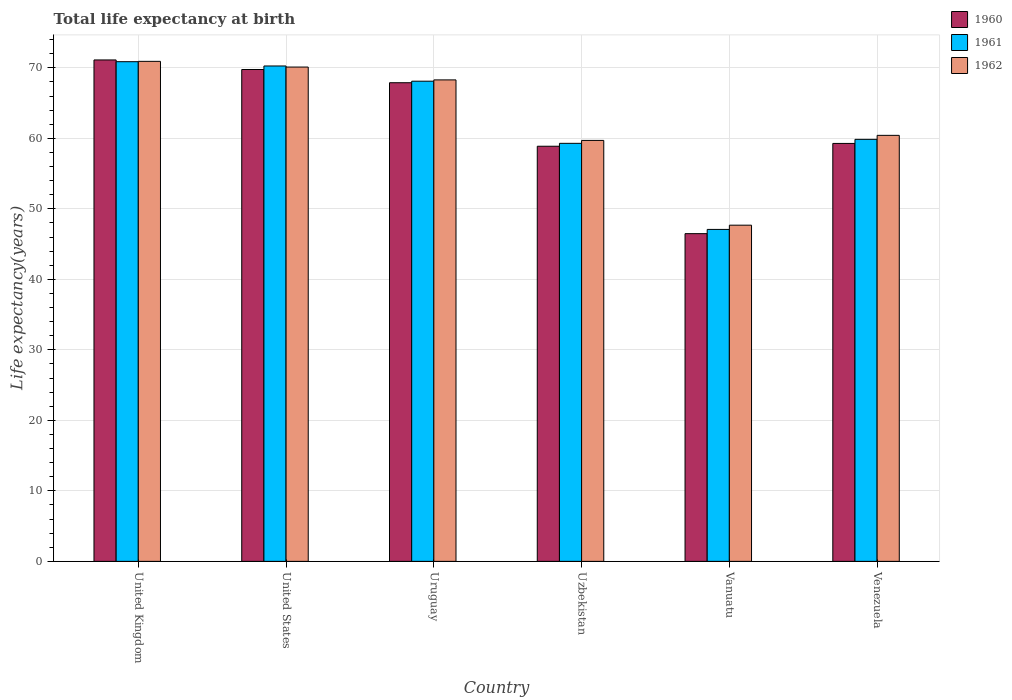How many different coloured bars are there?
Make the answer very short. 3. How many groups of bars are there?
Offer a terse response. 6. Are the number of bars per tick equal to the number of legend labels?
Give a very brief answer. Yes. Are the number of bars on each tick of the X-axis equal?
Give a very brief answer. Yes. What is the label of the 4th group of bars from the left?
Offer a very short reply. Uzbekistan. What is the life expectancy at birth in in 1960 in Venezuela?
Offer a very short reply. 59.29. Across all countries, what is the maximum life expectancy at birth in in 1962?
Give a very brief answer. 70.93. Across all countries, what is the minimum life expectancy at birth in in 1960?
Provide a succinct answer. 46.49. In which country was the life expectancy at birth in in 1960 maximum?
Your response must be concise. United Kingdom. In which country was the life expectancy at birth in in 1962 minimum?
Make the answer very short. Vanuatu. What is the total life expectancy at birth in in 1962 in the graph?
Give a very brief answer. 377.17. What is the difference between the life expectancy at birth in in 1960 in United States and that in Vanuatu?
Ensure brevity in your answer.  23.28. What is the difference between the life expectancy at birth in in 1960 in Venezuela and the life expectancy at birth in in 1961 in Vanuatu?
Provide a short and direct response. 12.2. What is the average life expectancy at birth in in 1961 per country?
Your response must be concise. 62.58. What is the difference between the life expectancy at birth in of/in 1962 and life expectancy at birth in of/in 1961 in Vanuatu?
Give a very brief answer. 0.6. What is the ratio of the life expectancy at birth in in 1960 in United States to that in Vanuatu?
Offer a terse response. 1.5. Is the life expectancy at birth in in 1962 in Uzbekistan less than that in Venezuela?
Provide a short and direct response. Yes. What is the difference between the highest and the second highest life expectancy at birth in in 1962?
Offer a very short reply. 1.82. What is the difference between the highest and the lowest life expectancy at birth in in 1962?
Your answer should be very brief. 23.24. Is the sum of the life expectancy at birth in in 1961 in Uzbekistan and Vanuatu greater than the maximum life expectancy at birth in in 1960 across all countries?
Keep it short and to the point. Yes. What does the 2nd bar from the right in Uzbekistan represents?
Offer a very short reply. 1961. Is it the case that in every country, the sum of the life expectancy at birth in in 1961 and life expectancy at birth in in 1960 is greater than the life expectancy at birth in in 1962?
Provide a short and direct response. Yes. How many bars are there?
Your answer should be very brief. 18. Are all the bars in the graph horizontal?
Ensure brevity in your answer.  No. Does the graph contain grids?
Offer a terse response. Yes. Where does the legend appear in the graph?
Provide a short and direct response. Top right. What is the title of the graph?
Offer a terse response. Total life expectancy at birth. Does "1977" appear as one of the legend labels in the graph?
Your answer should be compact. No. What is the label or title of the X-axis?
Make the answer very short. Country. What is the label or title of the Y-axis?
Your answer should be compact. Life expectancy(years). What is the Life expectancy(years) in 1960 in United Kingdom?
Give a very brief answer. 71.13. What is the Life expectancy(years) in 1961 in United Kingdom?
Offer a terse response. 70.88. What is the Life expectancy(years) of 1962 in United Kingdom?
Give a very brief answer. 70.93. What is the Life expectancy(years) in 1960 in United States?
Your response must be concise. 69.77. What is the Life expectancy(years) in 1961 in United States?
Make the answer very short. 70.27. What is the Life expectancy(years) in 1962 in United States?
Offer a terse response. 70.12. What is the Life expectancy(years) of 1960 in Uruguay?
Make the answer very short. 67.9. What is the Life expectancy(years) of 1961 in Uruguay?
Your response must be concise. 68.11. What is the Life expectancy(years) of 1962 in Uruguay?
Give a very brief answer. 68.3. What is the Life expectancy(years) in 1960 in Uzbekistan?
Your answer should be very brief. 58.89. What is the Life expectancy(years) in 1961 in Uzbekistan?
Offer a very short reply. 59.3. What is the Life expectancy(years) of 1962 in Uzbekistan?
Offer a very short reply. 59.71. What is the Life expectancy(years) in 1960 in Vanuatu?
Offer a terse response. 46.49. What is the Life expectancy(years) in 1961 in Vanuatu?
Your answer should be very brief. 47.09. What is the Life expectancy(years) of 1962 in Vanuatu?
Your response must be concise. 47.69. What is the Life expectancy(years) of 1960 in Venezuela?
Your answer should be compact. 59.29. What is the Life expectancy(years) in 1961 in Venezuela?
Give a very brief answer. 59.86. What is the Life expectancy(years) of 1962 in Venezuela?
Give a very brief answer. 60.43. Across all countries, what is the maximum Life expectancy(years) in 1960?
Offer a terse response. 71.13. Across all countries, what is the maximum Life expectancy(years) in 1961?
Ensure brevity in your answer.  70.88. Across all countries, what is the maximum Life expectancy(years) in 1962?
Your answer should be compact. 70.93. Across all countries, what is the minimum Life expectancy(years) of 1960?
Offer a terse response. 46.49. Across all countries, what is the minimum Life expectancy(years) of 1961?
Your response must be concise. 47.09. Across all countries, what is the minimum Life expectancy(years) of 1962?
Give a very brief answer. 47.69. What is the total Life expectancy(years) in 1960 in the graph?
Offer a very short reply. 373.45. What is the total Life expectancy(years) in 1961 in the graph?
Your answer should be compact. 375.51. What is the total Life expectancy(years) of 1962 in the graph?
Offer a terse response. 377.17. What is the difference between the Life expectancy(years) in 1960 in United Kingdom and that in United States?
Provide a succinct answer. 1.36. What is the difference between the Life expectancy(years) in 1961 in United Kingdom and that in United States?
Keep it short and to the point. 0.61. What is the difference between the Life expectancy(years) in 1962 in United Kingdom and that in United States?
Provide a succinct answer. 0.81. What is the difference between the Life expectancy(years) of 1960 in United Kingdom and that in Uruguay?
Offer a very short reply. 3.23. What is the difference between the Life expectancy(years) of 1961 in United Kingdom and that in Uruguay?
Your answer should be very brief. 2.77. What is the difference between the Life expectancy(years) in 1962 in United Kingdom and that in Uruguay?
Your response must be concise. 2.63. What is the difference between the Life expectancy(years) in 1960 in United Kingdom and that in Uzbekistan?
Your response must be concise. 12.24. What is the difference between the Life expectancy(years) of 1961 in United Kingdom and that in Uzbekistan?
Your response must be concise. 11.58. What is the difference between the Life expectancy(years) in 1962 in United Kingdom and that in Uzbekistan?
Ensure brevity in your answer.  11.21. What is the difference between the Life expectancy(years) in 1960 in United Kingdom and that in Vanuatu?
Provide a short and direct response. 24.64. What is the difference between the Life expectancy(years) in 1961 in United Kingdom and that in Vanuatu?
Give a very brief answer. 23.79. What is the difference between the Life expectancy(years) in 1962 in United Kingdom and that in Vanuatu?
Provide a succinct answer. 23.24. What is the difference between the Life expectancy(years) in 1960 in United Kingdom and that in Venezuela?
Provide a succinct answer. 11.84. What is the difference between the Life expectancy(years) of 1961 in United Kingdom and that in Venezuela?
Your answer should be compact. 11.02. What is the difference between the Life expectancy(years) in 1962 in United Kingdom and that in Venezuela?
Give a very brief answer. 10.5. What is the difference between the Life expectancy(years) in 1960 in United States and that in Uruguay?
Offer a very short reply. 1.87. What is the difference between the Life expectancy(years) of 1961 in United States and that in Uruguay?
Keep it short and to the point. 2.16. What is the difference between the Life expectancy(years) in 1962 in United States and that in Uruguay?
Keep it short and to the point. 1.82. What is the difference between the Life expectancy(years) of 1960 in United States and that in Uzbekistan?
Provide a short and direct response. 10.89. What is the difference between the Life expectancy(years) in 1961 in United States and that in Uzbekistan?
Provide a short and direct response. 10.97. What is the difference between the Life expectancy(years) in 1962 in United States and that in Uzbekistan?
Provide a short and direct response. 10.41. What is the difference between the Life expectancy(years) of 1960 in United States and that in Vanuatu?
Ensure brevity in your answer.  23.28. What is the difference between the Life expectancy(years) of 1961 in United States and that in Vanuatu?
Your answer should be very brief. 23.18. What is the difference between the Life expectancy(years) in 1962 in United States and that in Vanuatu?
Offer a very short reply. 22.43. What is the difference between the Life expectancy(years) in 1960 in United States and that in Venezuela?
Provide a succinct answer. 10.49. What is the difference between the Life expectancy(years) of 1961 in United States and that in Venezuela?
Your response must be concise. 10.41. What is the difference between the Life expectancy(years) in 1962 in United States and that in Venezuela?
Provide a short and direct response. 9.69. What is the difference between the Life expectancy(years) in 1960 in Uruguay and that in Uzbekistan?
Offer a very short reply. 9.01. What is the difference between the Life expectancy(years) in 1961 in Uruguay and that in Uzbekistan?
Keep it short and to the point. 8.82. What is the difference between the Life expectancy(years) in 1962 in Uruguay and that in Uzbekistan?
Keep it short and to the point. 8.58. What is the difference between the Life expectancy(years) in 1960 in Uruguay and that in Vanuatu?
Your answer should be very brief. 21.41. What is the difference between the Life expectancy(years) in 1961 in Uruguay and that in Vanuatu?
Provide a succinct answer. 21.02. What is the difference between the Life expectancy(years) of 1962 in Uruguay and that in Vanuatu?
Your answer should be very brief. 20.61. What is the difference between the Life expectancy(years) in 1960 in Uruguay and that in Venezuela?
Your answer should be very brief. 8.61. What is the difference between the Life expectancy(years) in 1961 in Uruguay and that in Venezuela?
Ensure brevity in your answer.  8.25. What is the difference between the Life expectancy(years) of 1962 in Uruguay and that in Venezuela?
Your answer should be compact. 7.87. What is the difference between the Life expectancy(years) of 1960 in Uzbekistan and that in Vanuatu?
Give a very brief answer. 12.4. What is the difference between the Life expectancy(years) in 1961 in Uzbekistan and that in Vanuatu?
Your answer should be compact. 12.21. What is the difference between the Life expectancy(years) of 1962 in Uzbekistan and that in Vanuatu?
Make the answer very short. 12.02. What is the difference between the Life expectancy(years) of 1960 in Uzbekistan and that in Venezuela?
Your answer should be compact. -0.4. What is the difference between the Life expectancy(years) of 1961 in Uzbekistan and that in Venezuela?
Your response must be concise. -0.56. What is the difference between the Life expectancy(years) in 1962 in Uzbekistan and that in Venezuela?
Your answer should be very brief. -0.72. What is the difference between the Life expectancy(years) in 1960 in Vanuatu and that in Venezuela?
Offer a very short reply. -12.8. What is the difference between the Life expectancy(years) of 1961 in Vanuatu and that in Venezuela?
Your answer should be very brief. -12.77. What is the difference between the Life expectancy(years) of 1962 in Vanuatu and that in Venezuela?
Your answer should be compact. -12.74. What is the difference between the Life expectancy(years) of 1960 in United Kingdom and the Life expectancy(years) of 1961 in United States?
Provide a short and direct response. 0.86. What is the difference between the Life expectancy(years) of 1960 in United Kingdom and the Life expectancy(years) of 1962 in United States?
Your answer should be very brief. 1.01. What is the difference between the Life expectancy(years) in 1961 in United Kingdom and the Life expectancy(years) in 1962 in United States?
Give a very brief answer. 0.76. What is the difference between the Life expectancy(years) in 1960 in United Kingdom and the Life expectancy(years) in 1961 in Uruguay?
Offer a very short reply. 3.01. What is the difference between the Life expectancy(years) in 1960 in United Kingdom and the Life expectancy(years) in 1962 in Uruguay?
Ensure brevity in your answer.  2.83. What is the difference between the Life expectancy(years) in 1961 in United Kingdom and the Life expectancy(years) in 1962 in Uruguay?
Provide a short and direct response. 2.58. What is the difference between the Life expectancy(years) in 1960 in United Kingdom and the Life expectancy(years) in 1961 in Uzbekistan?
Keep it short and to the point. 11.83. What is the difference between the Life expectancy(years) of 1960 in United Kingdom and the Life expectancy(years) of 1962 in Uzbekistan?
Your answer should be very brief. 11.41. What is the difference between the Life expectancy(years) of 1961 in United Kingdom and the Life expectancy(years) of 1962 in Uzbekistan?
Make the answer very short. 11.16. What is the difference between the Life expectancy(years) of 1960 in United Kingdom and the Life expectancy(years) of 1961 in Vanuatu?
Make the answer very short. 24.04. What is the difference between the Life expectancy(years) of 1960 in United Kingdom and the Life expectancy(years) of 1962 in Vanuatu?
Keep it short and to the point. 23.44. What is the difference between the Life expectancy(years) of 1961 in United Kingdom and the Life expectancy(years) of 1962 in Vanuatu?
Make the answer very short. 23.19. What is the difference between the Life expectancy(years) in 1960 in United Kingdom and the Life expectancy(years) in 1961 in Venezuela?
Offer a very short reply. 11.26. What is the difference between the Life expectancy(years) in 1960 in United Kingdom and the Life expectancy(years) in 1962 in Venezuela?
Make the answer very short. 10.7. What is the difference between the Life expectancy(years) in 1961 in United Kingdom and the Life expectancy(years) in 1962 in Venezuela?
Provide a short and direct response. 10.45. What is the difference between the Life expectancy(years) in 1960 in United States and the Life expectancy(years) in 1961 in Uruguay?
Offer a very short reply. 1.66. What is the difference between the Life expectancy(years) of 1960 in United States and the Life expectancy(years) of 1962 in Uruguay?
Keep it short and to the point. 1.47. What is the difference between the Life expectancy(years) in 1961 in United States and the Life expectancy(years) in 1962 in Uruguay?
Offer a terse response. 1.97. What is the difference between the Life expectancy(years) in 1960 in United States and the Life expectancy(years) in 1961 in Uzbekistan?
Provide a short and direct response. 10.47. What is the difference between the Life expectancy(years) of 1960 in United States and the Life expectancy(years) of 1962 in Uzbekistan?
Make the answer very short. 10.06. What is the difference between the Life expectancy(years) in 1961 in United States and the Life expectancy(years) in 1962 in Uzbekistan?
Provide a short and direct response. 10.56. What is the difference between the Life expectancy(years) of 1960 in United States and the Life expectancy(years) of 1961 in Vanuatu?
Give a very brief answer. 22.68. What is the difference between the Life expectancy(years) in 1960 in United States and the Life expectancy(years) in 1962 in Vanuatu?
Offer a terse response. 22.08. What is the difference between the Life expectancy(years) of 1961 in United States and the Life expectancy(years) of 1962 in Vanuatu?
Give a very brief answer. 22.58. What is the difference between the Life expectancy(years) of 1960 in United States and the Life expectancy(years) of 1961 in Venezuela?
Your response must be concise. 9.91. What is the difference between the Life expectancy(years) of 1960 in United States and the Life expectancy(years) of 1962 in Venezuela?
Offer a terse response. 9.34. What is the difference between the Life expectancy(years) in 1961 in United States and the Life expectancy(years) in 1962 in Venezuela?
Your answer should be very brief. 9.84. What is the difference between the Life expectancy(years) of 1960 in Uruguay and the Life expectancy(years) of 1961 in Uzbekistan?
Your response must be concise. 8.6. What is the difference between the Life expectancy(years) of 1960 in Uruguay and the Life expectancy(years) of 1962 in Uzbekistan?
Your response must be concise. 8.18. What is the difference between the Life expectancy(years) of 1961 in Uruguay and the Life expectancy(years) of 1962 in Uzbekistan?
Offer a terse response. 8.4. What is the difference between the Life expectancy(years) of 1960 in Uruguay and the Life expectancy(years) of 1961 in Vanuatu?
Give a very brief answer. 20.81. What is the difference between the Life expectancy(years) in 1960 in Uruguay and the Life expectancy(years) in 1962 in Vanuatu?
Make the answer very short. 20.21. What is the difference between the Life expectancy(years) of 1961 in Uruguay and the Life expectancy(years) of 1962 in Vanuatu?
Provide a short and direct response. 20.42. What is the difference between the Life expectancy(years) of 1960 in Uruguay and the Life expectancy(years) of 1961 in Venezuela?
Provide a short and direct response. 8.03. What is the difference between the Life expectancy(years) in 1960 in Uruguay and the Life expectancy(years) in 1962 in Venezuela?
Ensure brevity in your answer.  7.47. What is the difference between the Life expectancy(years) of 1961 in Uruguay and the Life expectancy(years) of 1962 in Venezuela?
Give a very brief answer. 7.68. What is the difference between the Life expectancy(years) in 1960 in Uzbekistan and the Life expectancy(years) in 1961 in Vanuatu?
Offer a terse response. 11.8. What is the difference between the Life expectancy(years) in 1960 in Uzbekistan and the Life expectancy(years) in 1962 in Vanuatu?
Keep it short and to the point. 11.2. What is the difference between the Life expectancy(years) in 1961 in Uzbekistan and the Life expectancy(years) in 1962 in Vanuatu?
Provide a short and direct response. 11.61. What is the difference between the Life expectancy(years) in 1960 in Uzbekistan and the Life expectancy(years) in 1961 in Venezuela?
Provide a succinct answer. -0.98. What is the difference between the Life expectancy(years) of 1960 in Uzbekistan and the Life expectancy(years) of 1962 in Venezuela?
Your answer should be very brief. -1.54. What is the difference between the Life expectancy(years) of 1961 in Uzbekistan and the Life expectancy(years) of 1962 in Venezuela?
Ensure brevity in your answer.  -1.13. What is the difference between the Life expectancy(years) in 1960 in Vanuatu and the Life expectancy(years) in 1961 in Venezuela?
Offer a very short reply. -13.38. What is the difference between the Life expectancy(years) of 1960 in Vanuatu and the Life expectancy(years) of 1962 in Venezuela?
Ensure brevity in your answer.  -13.94. What is the difference between the Life expectancy(years) of 1961 in Vanuatu and the Life expectancy(years) of 1962 in Venezuela?
Make the answer very short. -13.34. What is the average Life expectancy(years) of 1960 per country?
Your response must be concise. 62.24. What is the average Life expectancy(years) in 1961 per country?
Offer a very short reply. 62.59. What is the average Life expectancy(years) of 1962 per country?
Your answer should be very brief. 62.86. What is the difference between the Life expectancy(years) of 1960 and Life expectancy(years) of 1961 in United Kingdom?
Provide a succinct answer. 0.25. What is the difference between the Life expectancy(years) of 1961 and Life expectancy(years) of 1962 in United Kingdom?
Your answer should be very brief. -0.05. What is the difference between the Life expectancy(years) in 1960 and Life expectancy(years) in 1961 in United States?
Provide a short and direct response. -0.5. What is the difference between the Life expectancy(years) in 1960 and Life expectancy(years) in 1962 in United States?
Give a very brief answer. -0.35. What is the difference between the Life expectancy(years) of 1961 and Life expectancy(years) of 1962 in United States?
Provide a succinct answer. 0.15. What is the difference between the Life expectancy(years) in 1960 and Life expectancy(years) in 1961 in Uruguay?
Provide a short and direct response. -0.22. What is the difference between the Life expectancy(years) of 1960 and Life expectancy(years) of 1962 in Uruguay?
Offer a terse response. -0.4. What is the difference between the Life expectancy(years) of 1961 and Life expectancy(years) of 1962 in Uruguay?
Give a very brief answer. -0.18. What is the difference between the Life expectancy(years) in 1960 and Life expectancy(years) in 1961 in Uzbekistan?
Offer a very short reply. -0.41. What is the difference between the Life expectancy(years) of 1960 and Life expectancy(years) of 1962 in Uzbekistan?
Ensure brevity in your answer.  -0.83. What is the difference between the Life expectancy(years) in 1961 and Life expectancy(years) in 1962 in Uzbekistan?
Offer a terse response. -0.42. What is the difference between the Life expectancy(years) of 1960 and Life expectancy(years) of 1961 in Vanuatu?
Offer a very short reply. -0.6. What is the difference between the Life expectancy(years) in 1960 and Life expectancy(years) in 1962 in Vanuatu?
Provide a succinct answer. -1.2. What is the difference between the Life expectancy(years) in 1961 and Life expectancy(years) in 1962 in Vanuatu?
Your answer should be very brief. -0.6. What is the difference between the Life expectancy(years) of 1960 and Life expectancy(years) of 1961 in Venezuela?
Ensure brevity in your answer.  -0.58. What is the difference between the Life expectancy(years) of 1960 and Life expectancy(years) of 1962 in Venezuela?
Give a very brief answer. -1.15. What is the difference between the Life expectancy(years) in 1961 and Life expectancy(years) in 1962 in Venezuela?
Provide a succinct answer. -0.57. What is the ratio of the Life expectancy(years) of 1960 in United Kingdom to that in United States?
Your answer should be compact. 1.02. What is the ratio of the Life expectancy(years) of 1961 in United Kingdom to that in United States?
Offer a very short reply. 1.01. What is the ratio of the Life expectancy(years) of 1962 in United Kingdom to that in United States?
Provide a short and direct response. 1.01. What is the ratio of the Life expectancy(years) in 1960 in United Kingdom to that in Uruguay?
Your answer should be very brief. 1.05. What is the ratio of the Life expectancy(years) of 1961 in United Kingdom to that in Uruguay?
Your response must be concise. 1.04. What is the ratio of the Life expectancy(years) of 1962 in United Kingdom to that in Uruguay?
Your answer should be compact. 1.04. What is the ratio of the Life expectancy(years) of 1960 in United Kingdom to that in Uzbekistan?
Provide a succinct answer. 1.21. What is the ratio of the Life expectancy(years) of 1961 in United Kingdom to that in Uzbekistan?
Give a very brief answer. 1.2. What is the ratio of the Life expectancy(years) of 1962 in United Kingdom to that in Uzbekistan?
Give a very brief answer. 1.19. What is the ratio of the Life expectancy(years) in 1960 in United Kingdom to that in Vanuatu?
Offer a terse response. 1.53. What is the ratio of the Life expectancy(years) of 1961 in United Kingdom to that in Vanuatu?
Give a very brief answer. 1.51. What is the ratio of the Life expectancy(years) in 1962 in United Kingdom to that in Vanuatu?
Make the answer very short. 1.49. What is the ratio of the Life expectancy(years) in 1960 in United Kingdom to that in Venezuela?
Give a very brief answer. 1.2. What is the ratio of the Life expectancy(years) in 1961 in United Kingdom to that in Venezuela?
Your response must be concise. 1.18. What is the ratio of the Life expectancy(years) in 1962 in United Kingdom to that in Venezuela?
Your answer should be very brief. 1.17. What is the ratio of the Life expectancy(years) of 1960 in United States to that in Uruguay?
Your response must be concise. 1.03. What is the ratio of the Life expectancy(years) in 1961 in United States to that in Uruguay?
Your answer should be very brief. 1.03. What is the ratio of the Life expectancy(years) of 1962 in United States to that in Uruguay?
Ensure brevity in your answer.  1.03. What is the ratio of the Life expectancy(years) in 1960 in United States to that in Uzbekistan?
Keep it short and to the point. 1.18. What is the ratio of the Life expectancy(years) of 1961 in United States to that in Uzbekistan?
Offer a terse response. 1.19. What is the ratio of the Life expectancy(years) in 1962 in United States to that in Uzbekistan?
Provide a short and direct response. 1.17. What is the ratio of the Life expectancy(years) in 1960 in United States to that in Vanuatu?
Keep it short and to the point. 1.5. What is the ratio of the Life expectancy(years) in 1961 in United States to that in Vanuatu?
Provide a short and direct response. 1.49. What is the ratio of the Life expectancy(years) of 1962 in United States to that in Vanuatu?
Keep it short and to the point. 1.47. What is the ratio of the Life expectancy(years) in 1960 in United States to that in Venezuela?
Provide a succinct answer. 1.18. What is the ratio of the Life expectancy(years) in 1961 in United States to that in Venezuela?
Your answer should be compact. 1.17. What is the ratio of the Life expectancy(years) of 1962 in United States to that in Venezuela?
Give a very brief answer. 1.16. What is the ratio of the Life expectancy(years) of 1960 in Uruguay to that in Uzbekistan?
Your answer should be very brief. 1.15. What is the ratio of the Life expectancy(years) in 1961 in Uruguay to that in Uzbekistan?
Provide a short and direct response. 1.15. What is the ratio of the Life expectancy(years) in 1962 in Uruguay to that in Uzbekistan?
Your answer should be very brief. 1.14. What is the ratio of the Life expectancy(years) of 1960 in Uruguay to that in Vanuatu?
Ensure brevity in your answer.  1.46. What is the ratio of the Life expectancy(years) of 1961 in Uruguay to that in Vanuatu?
Keep it short and to the point. 1.45. What is the ratio of the Life expectancy(years) of 1962 in Uruguay to that in Vanuatu?
Offer a very short reply. 1.43. What is the ratio of the Life expectancy(years) in 1960 in Uruguay to that in Venezuela?
Make the answer very short. 1.15. What is the ratio of the Life expectancy(years) in 1961 in Uruguay to that in Venezuela?
Keep it short and to the point. 1.14. What is the ratio of the Life expectancy(years) of 1962 in Uruguay to that in Venezuela?
Make the answer very short. 1.13. What is the ratio of the Life expectancy(years) in 1960 in Uzbekistan to that in Vanuatu?
Your answer should be compact. 1.27. What is the ratio of the Life expectancy(years) of 1961 in Uzbekistan to that in Vanuatu?
Provide a short and direct response. 1.26. What is the ratio of the Life expectancy(years) of 1962 in Uzbekistan to that in Vanuatu?
Give a very brief answer. 1.25. What is the ratio of the Life expectancy(years) of 1961 in Uzbekistan to that in Venezuela?
Provide a short and direct response. 0.99. What is the ratio of the Life expectancy(years) in 1960 in Vanuatu to that in Venezuela?
Keep it short and to the point. 0.78. What is the ratio of the Life expectancy(years) in 1961 in Vanuatu to that in Venezuela?
Keep it short and to the point. 0.79. What is the ratio of the Life expectancy(years) in 1962 in Vanuatu to that in Venezuela?
Offer a terse response. 0.79. What is the difference between the highest and the second highest Life expectancy(years) in 1960?
Offer a terse response. 1.36. What is the difference between the highest and the second highest Life expectancy(years) of 1961?
Your answer should be compact. 0.61. What is the difference between the highest and the second highest Life expectancy(years) of 1962?
Make the answer very short. 0.81. What is the difference between the highest and the lowest Life expectancy(years) in 1960?
Your answer should be compact. 24.64. What is the difference between the highest and the lowest Life expectancy(years) of 1961?
Provide a succinct answer. 23.79. What is the difference between the highest and the lowest Life expectancy(years) in 1962?
Your answer should be compact. 23.24. 